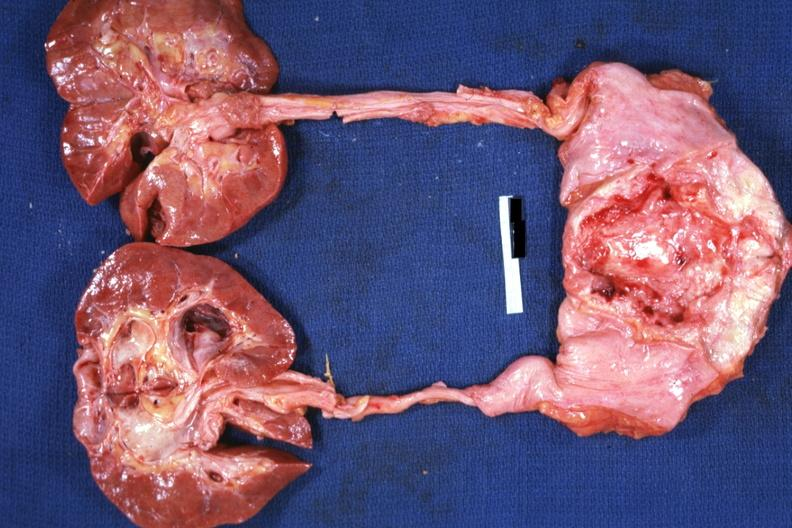what is present?
Answer the question using a single word or phrase. Prostate 